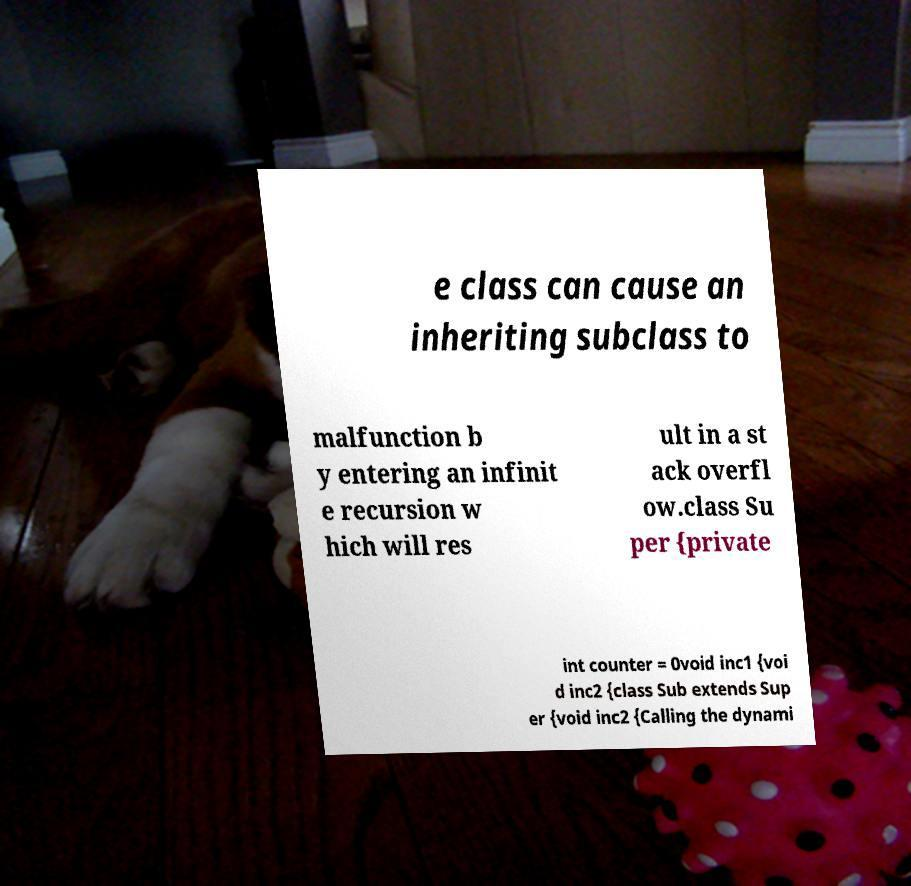What messages or text are displayed in this image? I need them in a readable, typed format. e class can cause an inheriting subclass to malfunction b y entering an infinit e recursion w hich will res ult in a st ack overfl ow.class Su per {private int counter = 0void inc1 {voi d inc2 {class Sub extends Sup er {void inc2 {Calling the dynami 